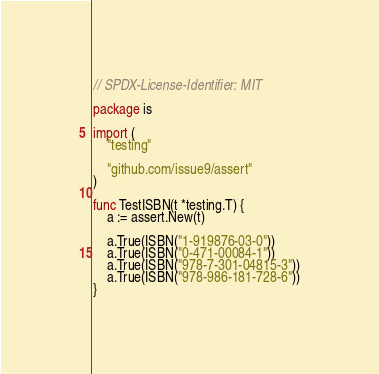Convert code to text. <code><loc_0><loc_0><loc_500><loc_500><_Go_>// SPDX-License-Identifier: MIT

package is

import (
	"testing"

	"github.com/issue9/assert"
)

func TestISBN(t *testing.T) {
	a := assert.New(t)

	a.True(ISBN("1-919876-03-0"))
	a.True(ISBN("0-471-00084-1"))
	a.True(ISBN("978-7-301-04815-3"))
	a.True(ISBN("978-986-181-728-6"))
}
</code> 